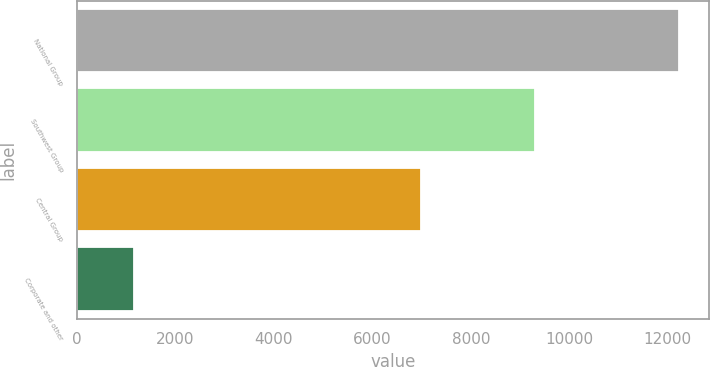<chart> <loc_0><loc_0><loc_500><loc_500><bar_chart><fcel>National Group<fcel>Southwest Group<fcel>Central Group<fcel>Corporate and other<nl><fcel>12224<fcel>9311<fcel>6982<fcel>1165<nl></chart> 